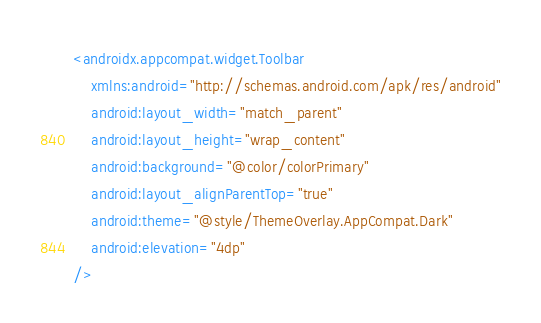Convert code to text. <code><loc_0><loc_0><loc_500><loc_500><_XML_><androidx.appcompat.widget.Toolbar
    xmlns:android="http://schemas.android.com/apk/res/android"
    android:layout_width="match_parent"
    android:layout_height="wrap_content"
    android:background="@color/colorPrimary"
    android:layout_alignParentTop="true"
    android:theme="@style/ThemeOverlay.AppCompat.Dark"
    android:elevation="4dp"
/></code> 